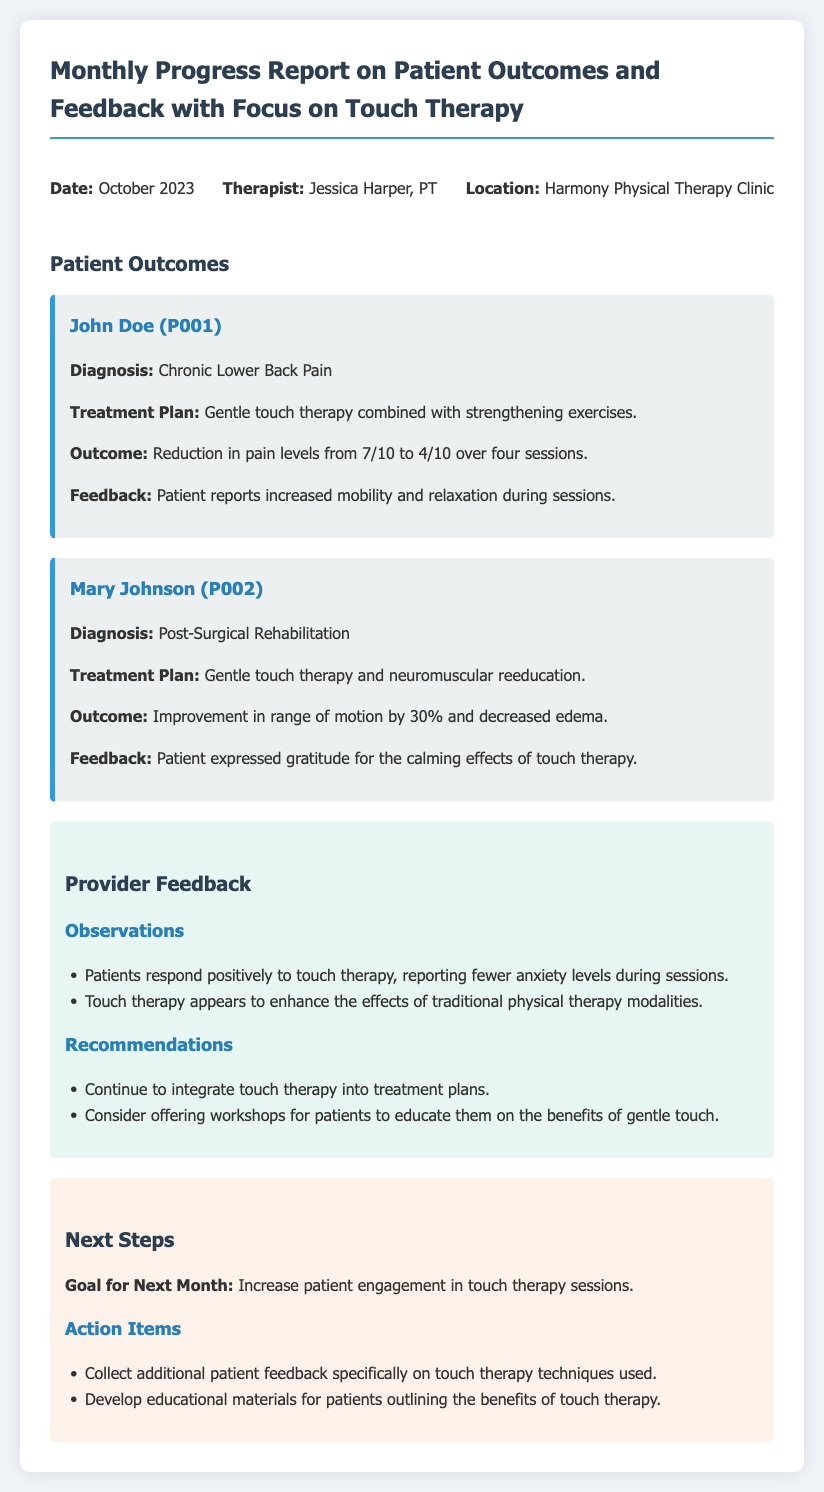What is the date of the report? The date is mentioned in the header information section of the document.
Answer: October 2023 Who is the therapist listed in the report? The therapist's name is stated in the header information section of the document.
Answer: Jessica Harper, PT What is the diagnosis for John Doe? John Doe's diagnosis is detailed in the patient outcomes section of the document.
Answer: Chronic Lower Back Pain What was the outcome for Mary Johnson? The outcome for Mary Johnson is summarized in the patient outcomes section of the document.
Answer: Improvement in range of motion by 30% and decreased edema What feedback did patients provide regarding touch therapy? The feedback from patients is included in the provider feedback section of the document.
Answer: Fewer anxiety levels during sessions What is the goal for next month? The goal is stated in the next steps section of the document.
Answer: Increase patient engagement in touch therapy sessions What are the action items listed in the next steps? The action items are specified in the next steps section of the document.
Answer: Collect additional patient feedback specifically on touch therapy techniques used How do patients feel about the calming effects of touch therapy? The feelings of patients regarding touch therapy are expressed in the feedback section of the document.
Answer: Expressed gratitude for the calming effects of touch therapy 